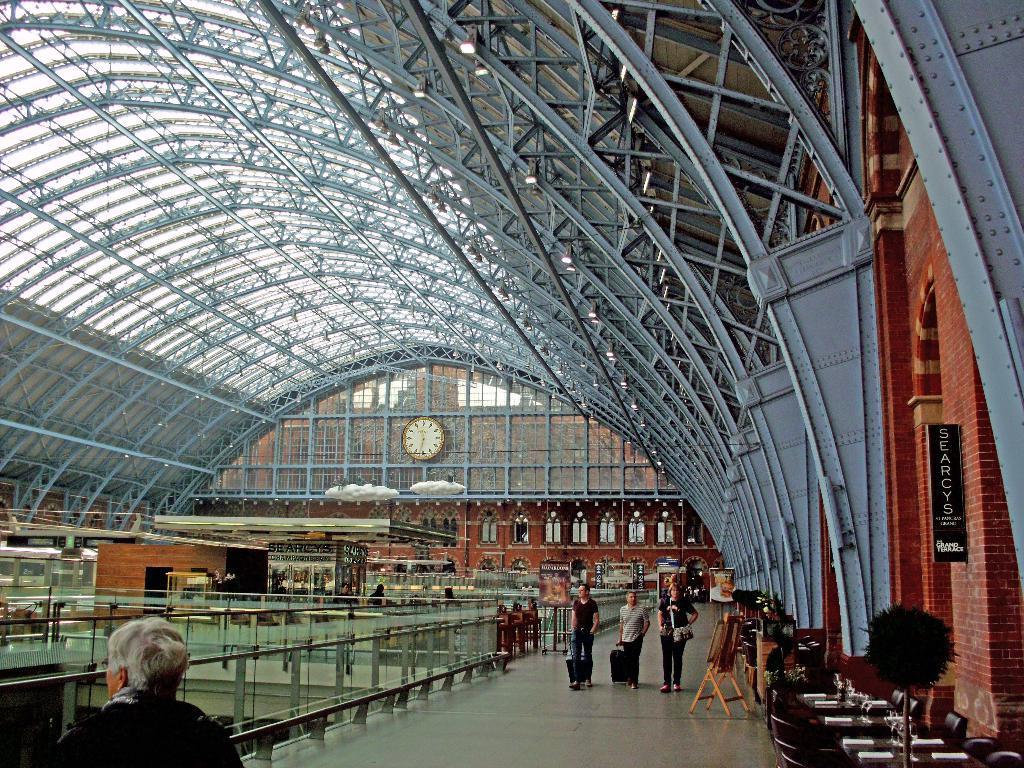Can you describe this image briefly? In this image we can see there are so many people walking on the floor under the iron roof behind them there are some painting boards and also there is a big clock on the building. 